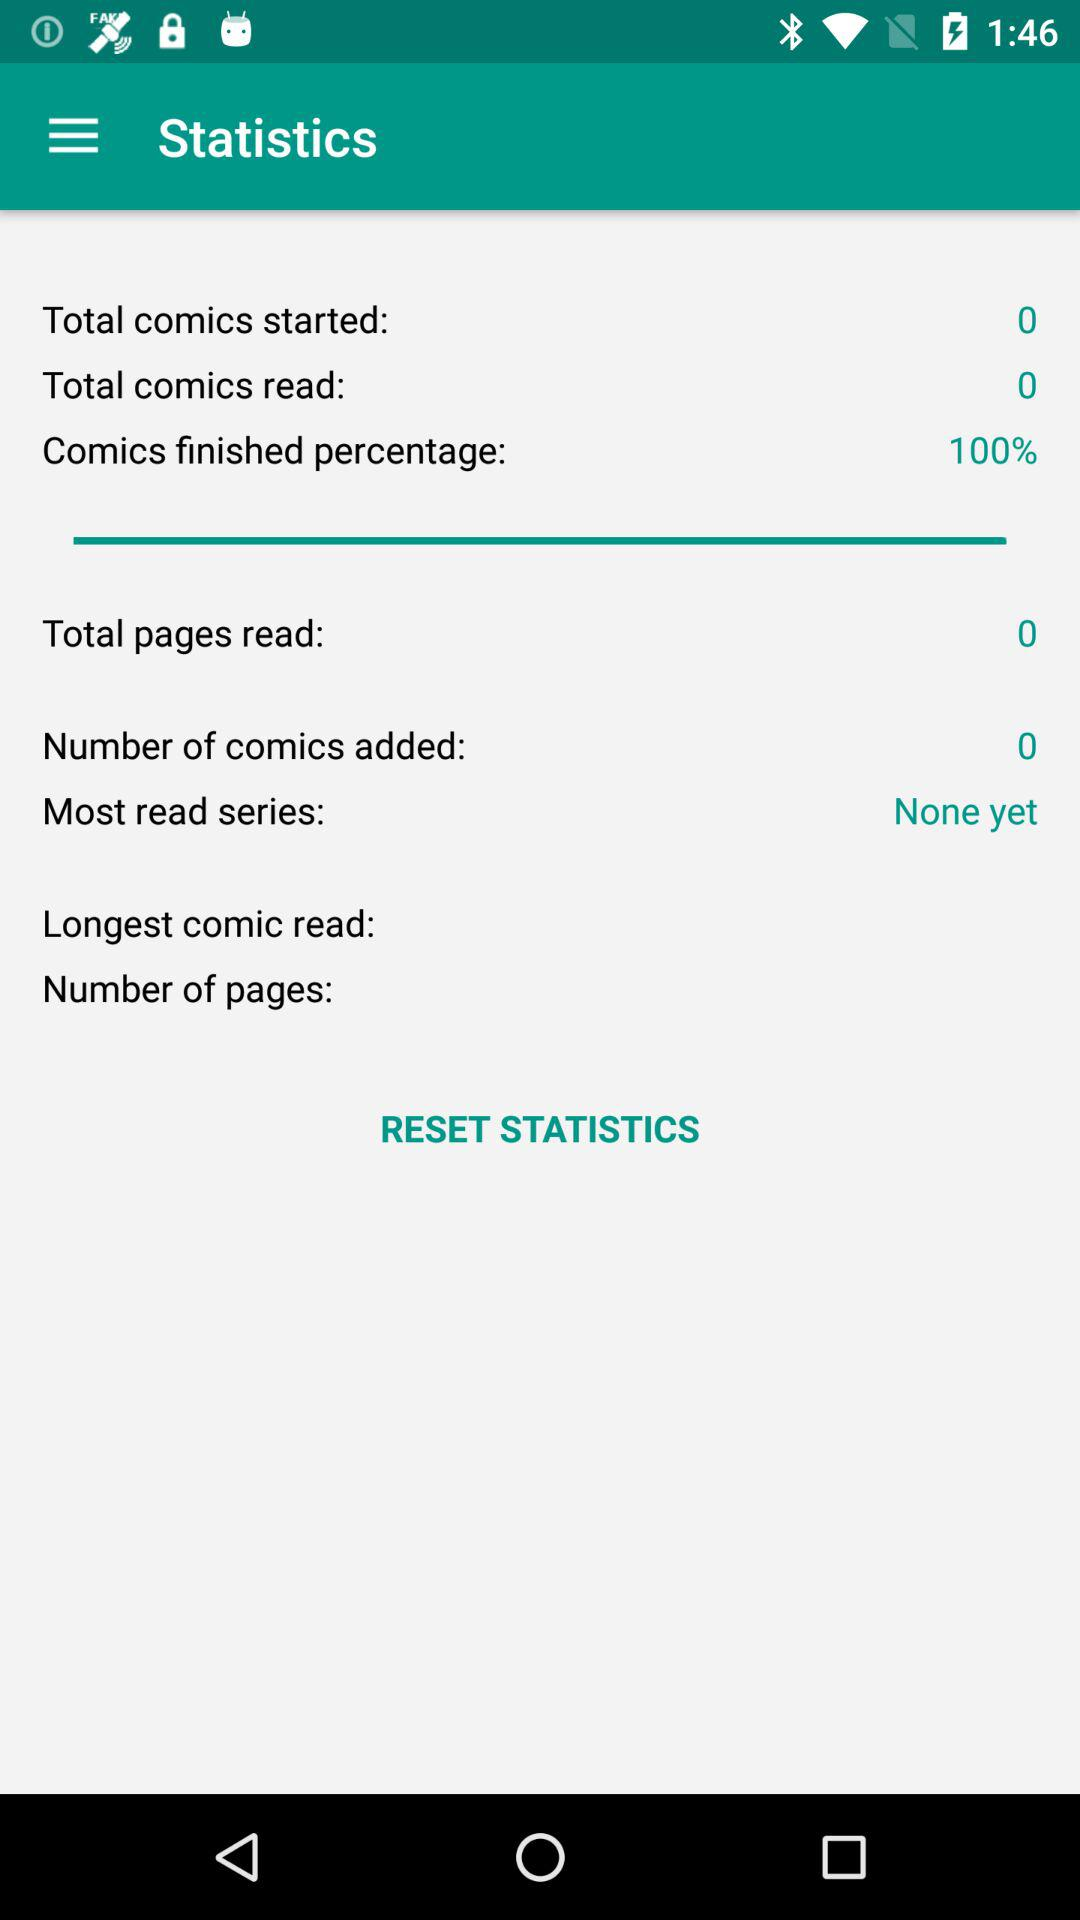How many more comics have I read than started?
Answer the question using a single word or phrase. 0 